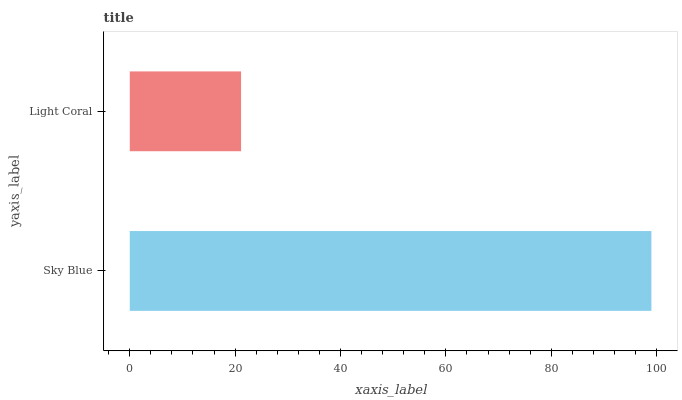Is Light Coral the minimum?
Answer yes or no. Yes. Is Sky Blue the maximum?
Answer yes or no. Yes. Is Light Coral the maximum?
Answer yes or no. No. Is Sky Blue greater than Light Coral?
Answer yes or no. Yes. Is Light Coral less than Sky Blue?
Answer yes or no. Yes. Is Light Coral greater than Sky Blue?
Answer yes or no. No. Is Sky Blue less than Light Coral?
Answer yes or no. No. Is Sky Blue the high median?
Answer yes or no. Yes. Is Light Coral the low median?
Answer yes or no. Yes. Is Light Coral the high median?
Answer yes or no. No. Is Sky Blue the low median?
Answer yes or no. No. 